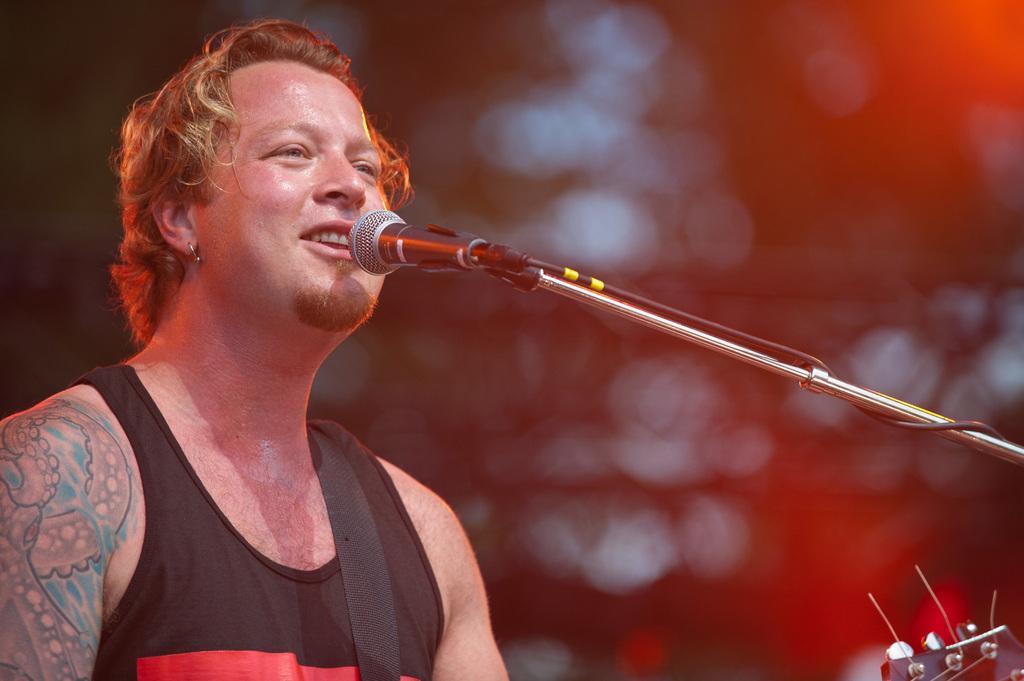Describe this image in one or two sentences. There is one person standing on the left side of this image, and there is a Mic in the middle of this image. 